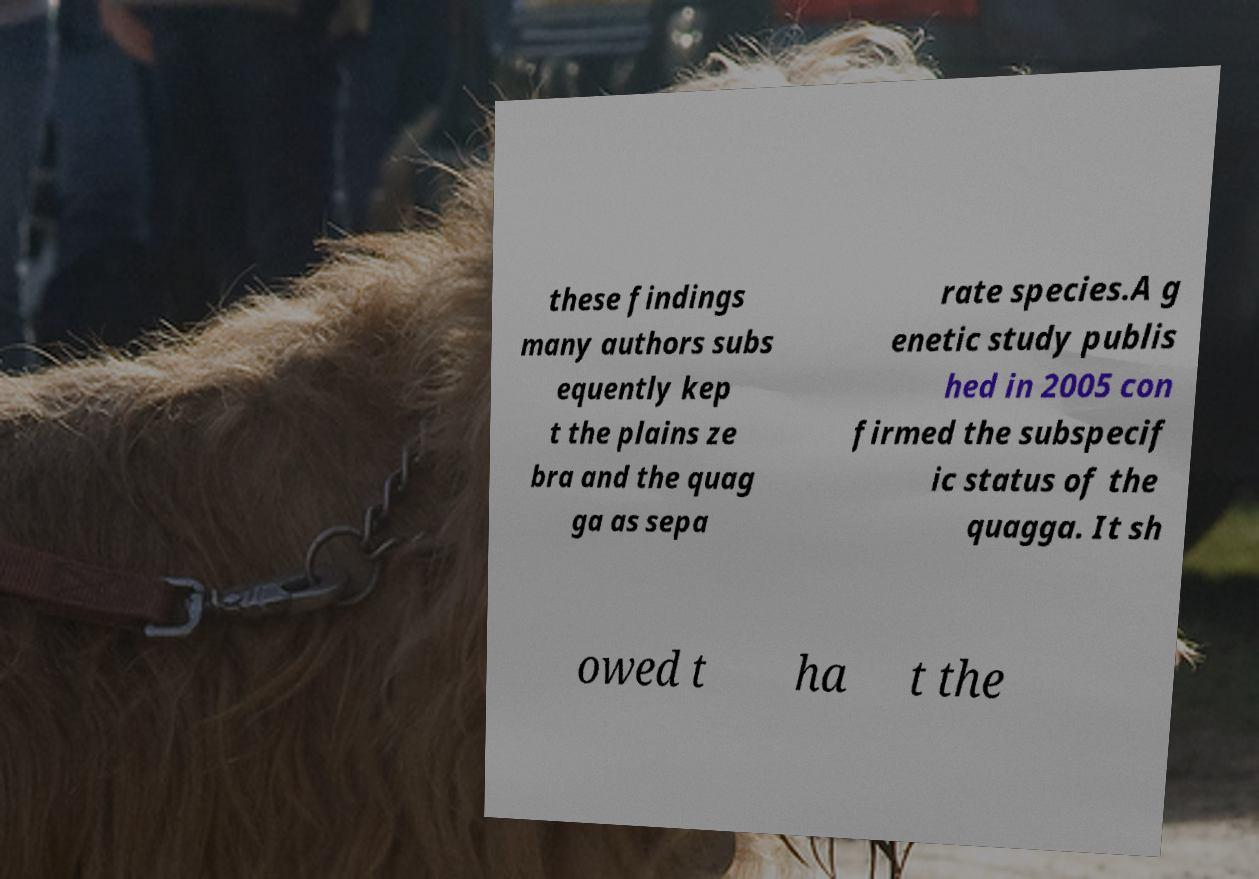What messages or text are displayed in this image? I need them in a readable, typed format. these findings many authors subs equently kep t the plains ze bra and the quag ga as sepa rate species.A g enetic study publis hed in 2005 con firmed the subspecif ic status of the quagga. It sh owed t ha t the 